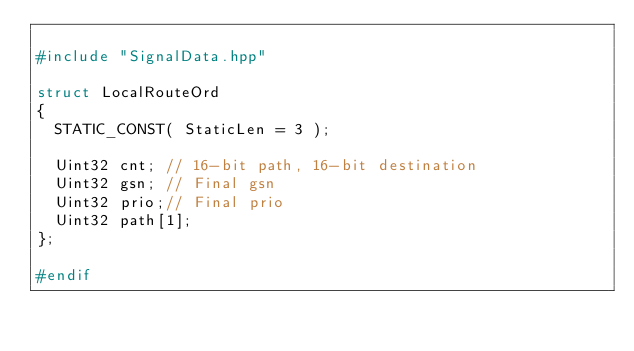Convert code to text. <code><loc_0><loc_0><loc_500><loc_500><_C++_>
#include "SignalData.hpp"

struct LocalRouteOrd
{
  STATIC_CONST( StaticLen = 3 );

  Uint32 cnt; // 16-bit path, 16-bit destination
  Uint32 gsn; // Final gsn
  Uint32 prio;// Final prio
  Uint32 path[1];
};

#endif
</code> 